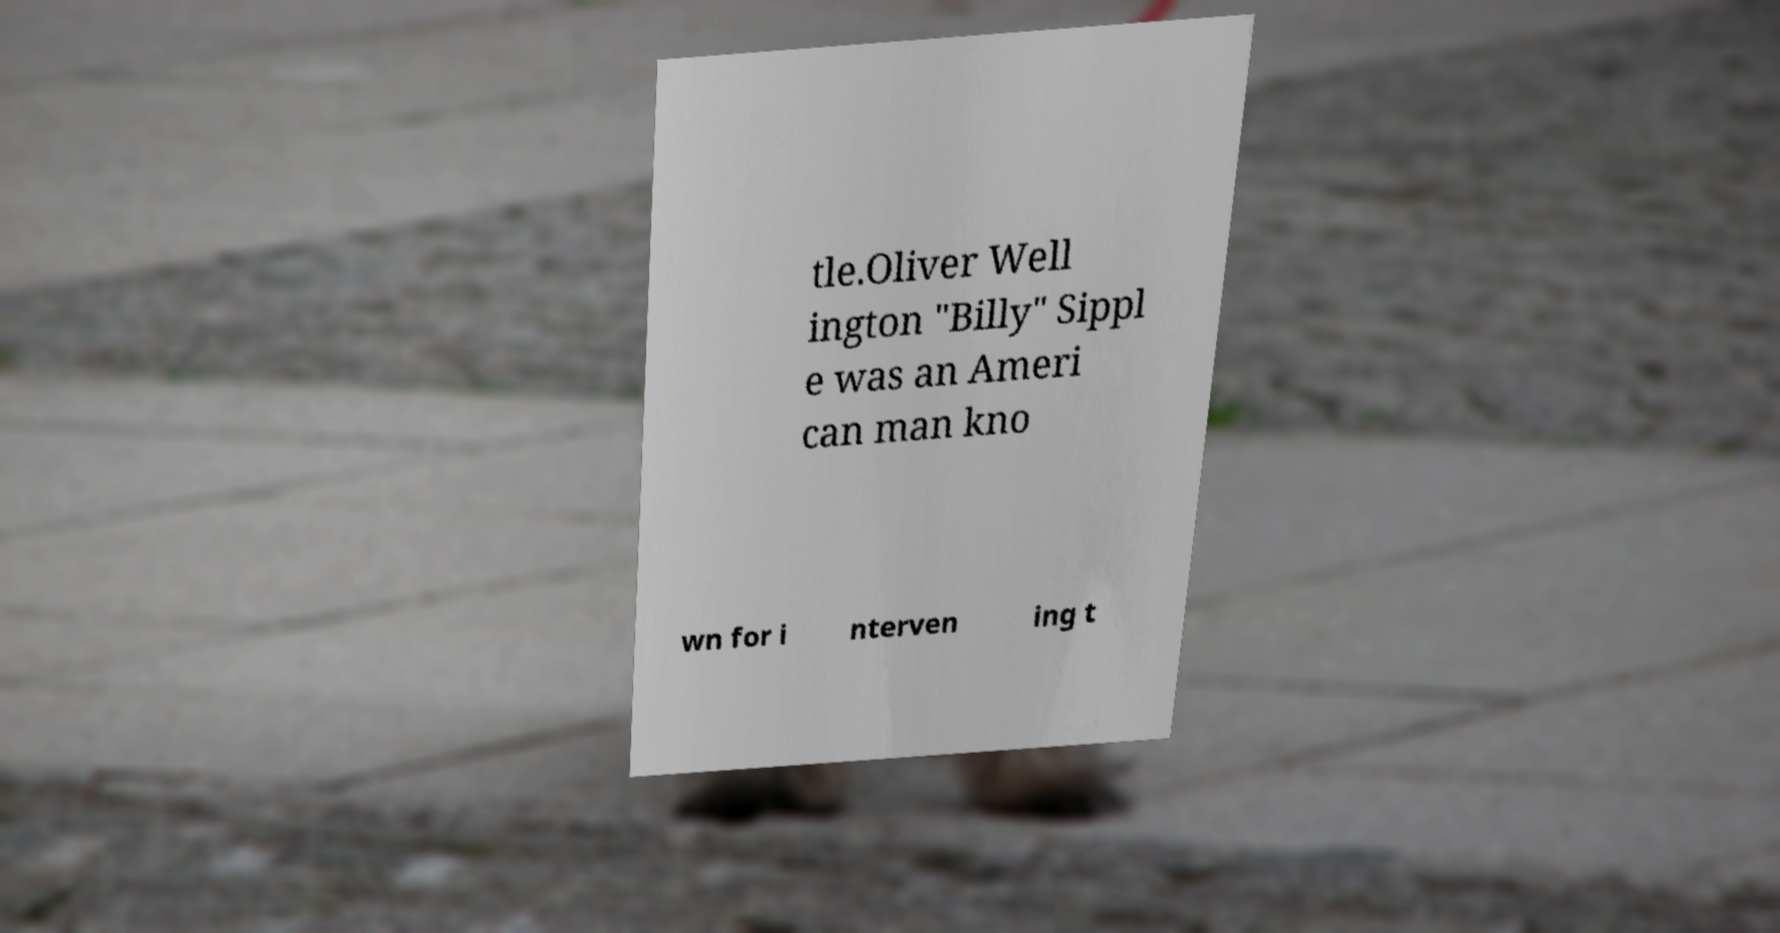What messages or text are displayed in this image? I need them in a readable, typed format. tle.Oliver Well ington "Billy" Sippl e was an Ameri can man kno wn for i nterven ing t 